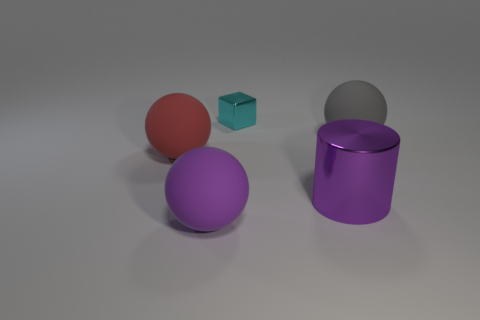Are there more large shiny cylinders in front of the tiny metallic object than gray matte things that are to the left of the red thing? Yes, there are indeed more large shiny cylinders; to be specific, there is one large purple shiny cylinder in front of the tiny metallic cube, compared to zero gray matte objects positioned to the left of the red sphere. 